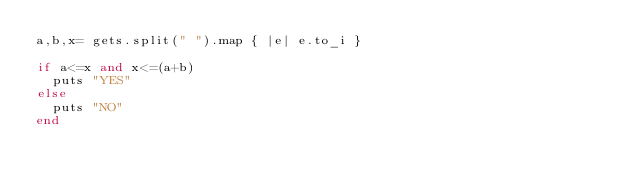<code> <loc_0><loc_0><loc_500><loc_500><_Ruby_>a,b,x= gets.split(" ").map { |e| e.to_i }

if a<=x and x<=(a+b)
  puts "YES"
else
  puts "NO"
end
</code> 